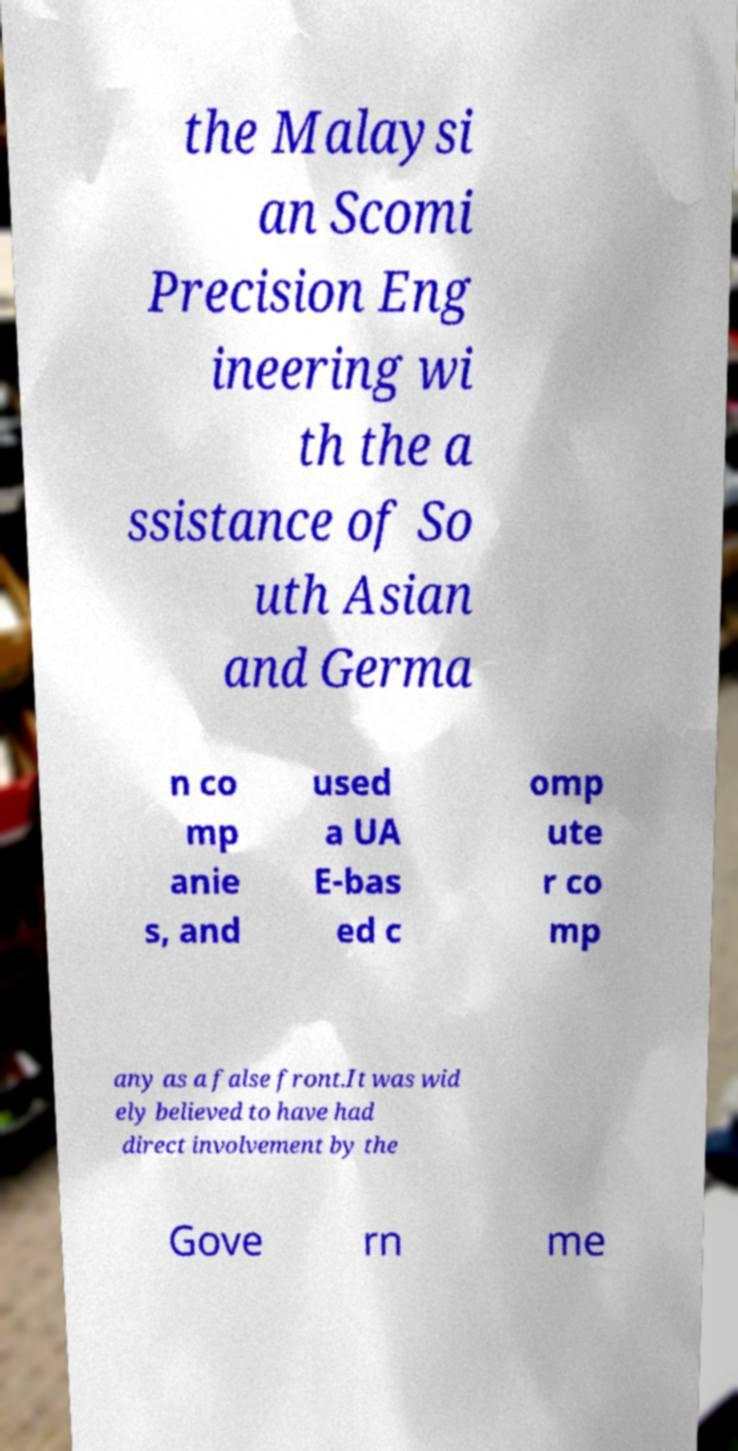I need the written content from this picture converted into text. Can you do that? the Malaysi an Scomi Precision Eng ineering wi th the a ssistance of So uth Asian and Germa n co mp anie s, and used a UA E-bas ed c omp ute r co mp any as a false front.It was wid ely believed to have had direct involvement by the Gove rn me 